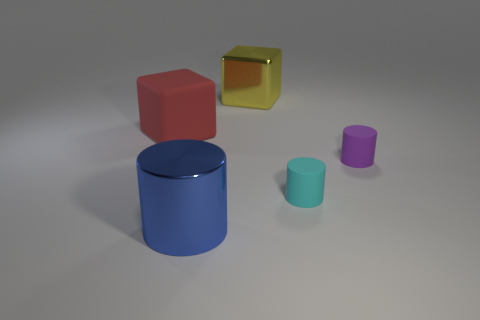Add 1 tiny matte blocks. How many objects exist? 6 Subtract all blocks. How many objects are left? 3 Subtract all large red matte cylinders. Subtract all small things. How many objects are left? 3 Add 2 tiny cylinders. How many tiny cylinders are left? 4 Add 4 small cyan rubber blocks. How many small cyan rubber blocks exist? 4 Subtract 0 purple spheres. How many objects are left? 5 